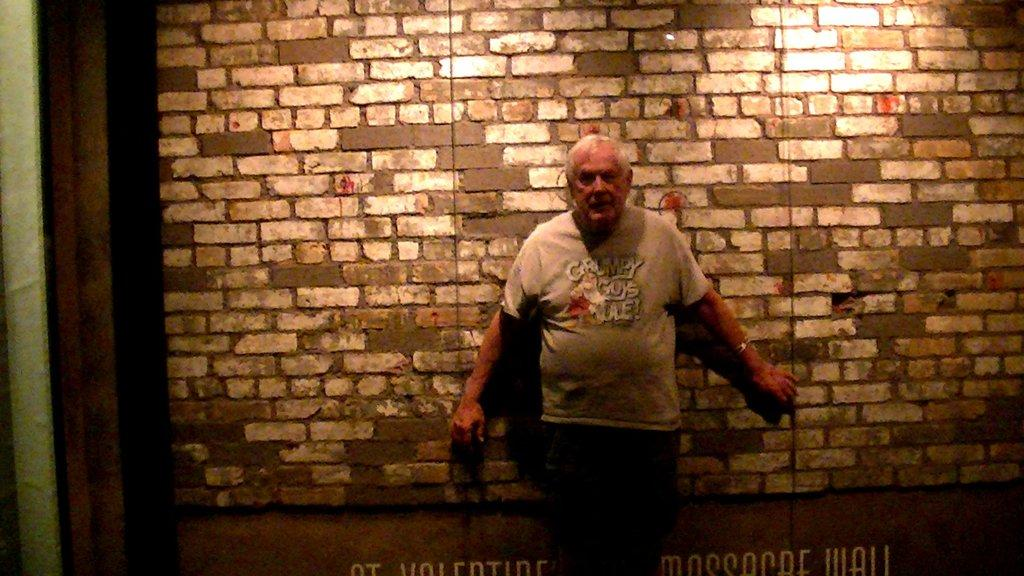What is the main subject of the image? There is a man standing in the image. Where is the man positioned in relation to the wall? The man is standing in front of a wall. What can be observed about the wall in the image? There is a light focus on the wall. What type of appliance is the man holding in the image? There is no appliance visible in the image; the man is not holding anything. 